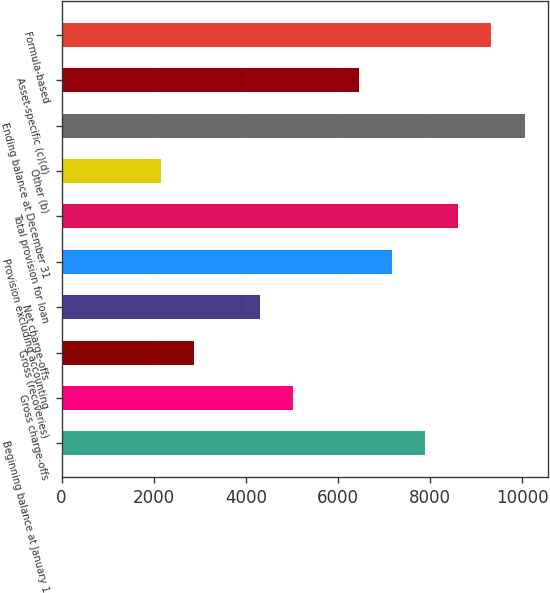Convert chart. <chart><loc_0><loc_0><loc_500><loc_500><bar_chart><fcel>Beginning balance at January 1<fcel>Gross charge-offs<fcel>Gross (recoveries)<fcel>Net charge-offs<fcel>Provision excluding accounting<fcel>Total provision for loan<fcel>Other (b)<fcel>Ending balance at December 31<fcel>Asset-specific (c)(d)<fcel>Formula-based<nl><fcel>7896.86<fcel>5025.34<fcel>2871.7<fcel>4307.46<fcel>7178.98<fcel>8614.74<fcel>2153.82<fcel>10050.5<fcel>6461.1<fcel>9332.62<nl></chart> 